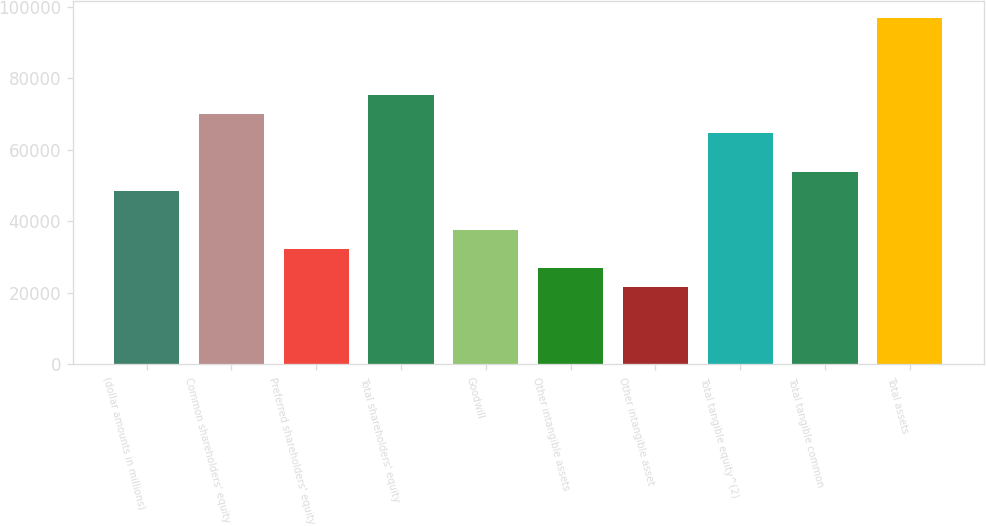<chart> <loc_0><loc_0><loc_500><loc_500><bar_chart><fcel>(dollar amounts in millions)<fcel>Common shareholders' equity<fcel>Preferred shareholders' equity<fcel>Total shareholders' equity<fcel>Goodwill<fcel>Other intangible assets<fcel>Other intangible asset<fcel>Total tangible equity^(2)<fcel>Total tangible common<fcel>Total assets<nl><fcel>48433.4<fcel>69956<fcel>32291.4<fcel>75336.6<fcel>37672.1<fcel>26910.8<fcel>21530.2<fcel>64575.3<fcel>53814<fcel>96859.2<nl></chart> 